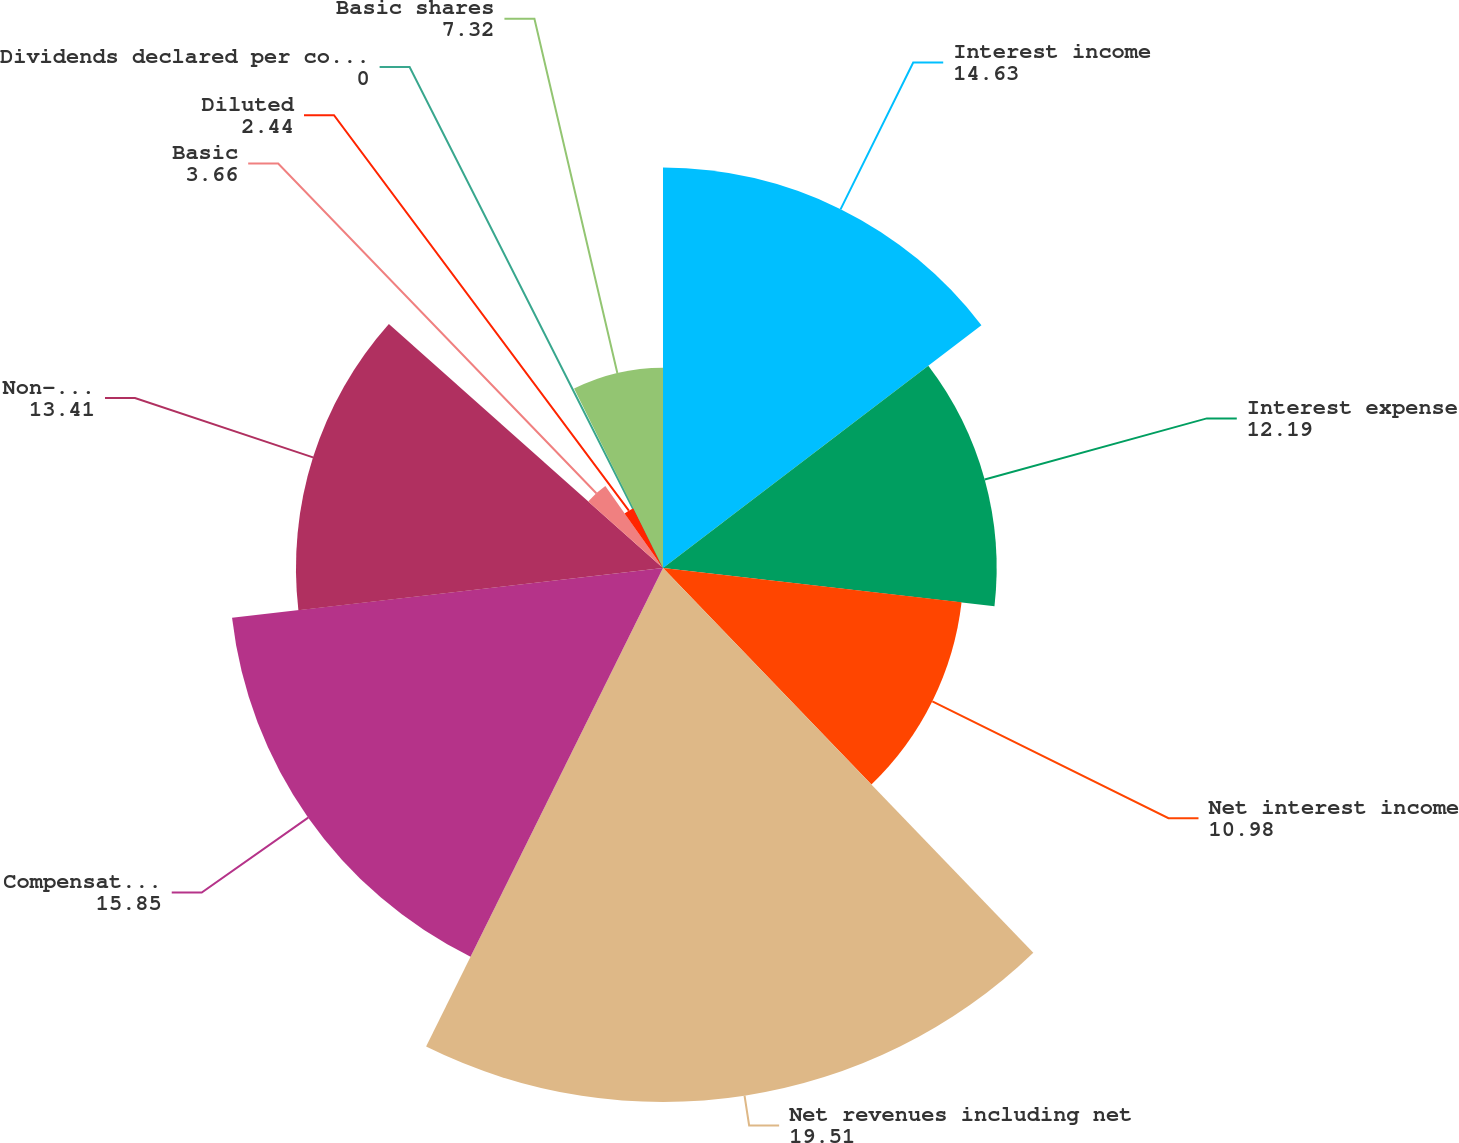<chart> <loc_0><loc_0><loc_500><loc_500><pie_chart><fcel>Interest income<fcel>Interest expense<fcel>Net interest income<fcel>Net revenues including net<fcel>Compensation and benefits<fcel>Non-compensation expenses<fcel>Basic<fcel>Diluted<fcel>Dividends declared per common<fcel>Basic shares<nl><fcel>14.63%<fcel>12.19%<fcel>10.98%<fcel>19.51%<fcel>15.85%<fcel>13.41%<fcel>3.66%<fcel>2.44%<fcel>0.0%<fcel>7.32%<nl></chart> 